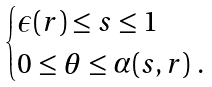<formula> <loc_0><loc_0><loc_500><loc_500>\begin{cases} \epsilon ( r ) \leq s \leq 1 \\ 0 \leq \theta \leq \alpha ( s , r ) \ . \end{cases}</formula> 